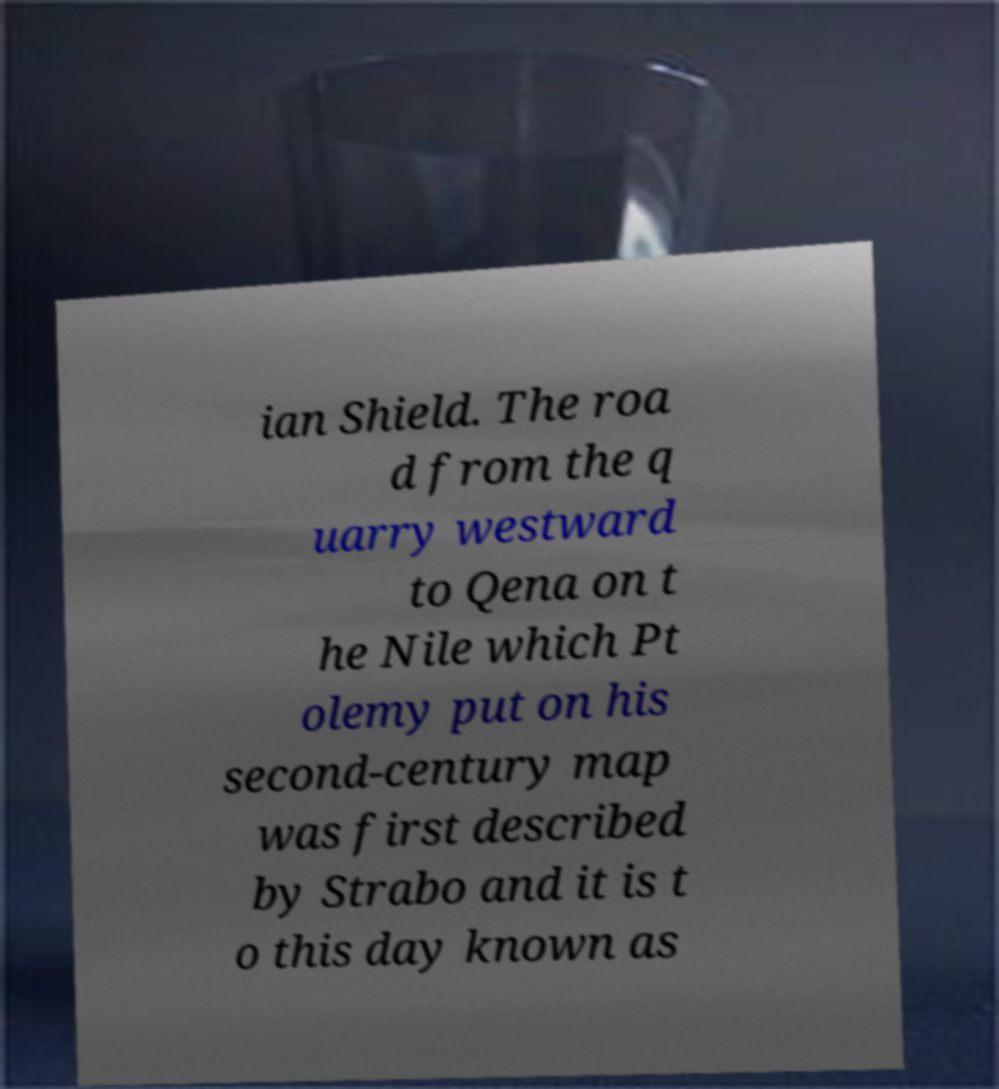Please identify and transcribe the text found in this image. ian Shield. The roa d from the q uarry westward to Qena on t he Nile which Pt olemy put on his second-century map was first described by Strabo and it is t o this day known as 